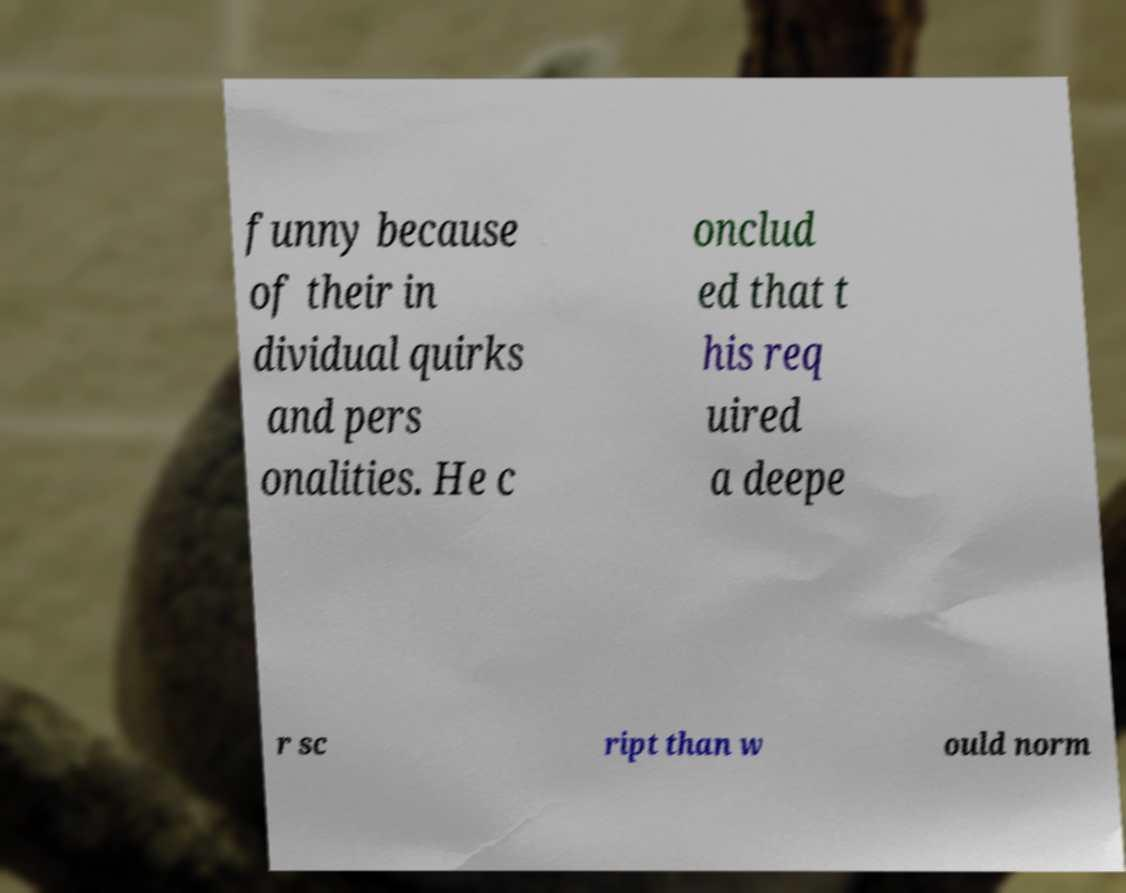Please identify and transcribe the text found in this image. funny because of their in dividual quirks and pers onalities. He c onclud ed that t his req uired a deepe r sc ript than w ould norm 